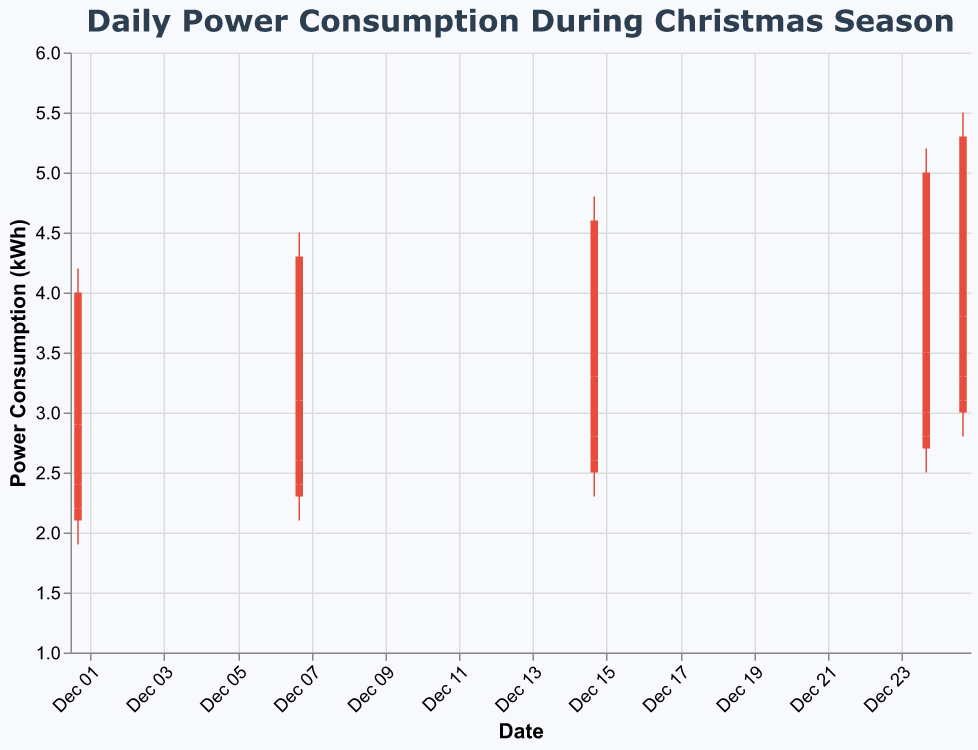What is the title of the chart? The title of the chart is displayed at the top and reads "Daily Power Consumption During Christmas Season".
Answer: Daily Power Consumption During Christmas Season What do the colors of the bars represent? The colors of the bars represent whether the power consumption closed higher or lower than it opened. Red indicates a rise (Close > Open) and green indicates a fall (Close < Open).
Answer: Rise or fall in power consumption Which date had the highest peak power consumption? By looking at the highest points of the bars across the dates, the date with the highest peak power consumption is December 25th at 18:00, reaching up to 5.5 kWh.
Answer: December 25 On which date was the power consumption the lowest at 00:00? By examining the Close values for the 00:00 time on each date, the lowest power consumption was on December 1st with 2.2 kWh.
Answer: December 1 What was the power consumption range on December 15 at 18:00? The range is calculated by the difference between the High and Low values. For December 15 at 18:00, the High was 4.8 kWh and the Low was 3.2 kWh. The range is 4.8 - 3.2 = 1.6 kWh.
Answer: 1.6 kWh How did the power consumption change from the morning (06:00) to the evening (18:00) on December 24? The Close value at 06:00 is 3.0 kWh and at 18:00 is 5.0 kWh, so the power consumption increased by 5.0 - 3.0 = 2.0 kWh from morning to evening.
Answer: Increased by 2.0 kWh Which date(s) show the highest difference between the High and Low values? By comparing the differences between the High and Low values for each date and time, December 24 at 18:00 has the highest difference with 5.2 kWh - 3.4 kWh = 1.8 kWh and December 25 at 18:00 also has a high difference with 5.5 kWh - 3.7 kWh = 1.8 kWh.
Answer: December 24 and December 25 What was the overall trend in power consumption on December 25 across the different times? Observing the Close values for December 25 at different times (00:00, 06:00, 12:00, 18:00), the power consumption shows an increasing trend: 3.1 kWh, 3.3 kWh, 3.8 kWh, 5.3 kWh.
Answer: Increasing trend What was the Close value at 12:00 on December 15? The Close value is directly shown in the data, indicating the power consumption was 3.3 kWh on December 15 at 12:00.
Answer: 3.3 kWh 